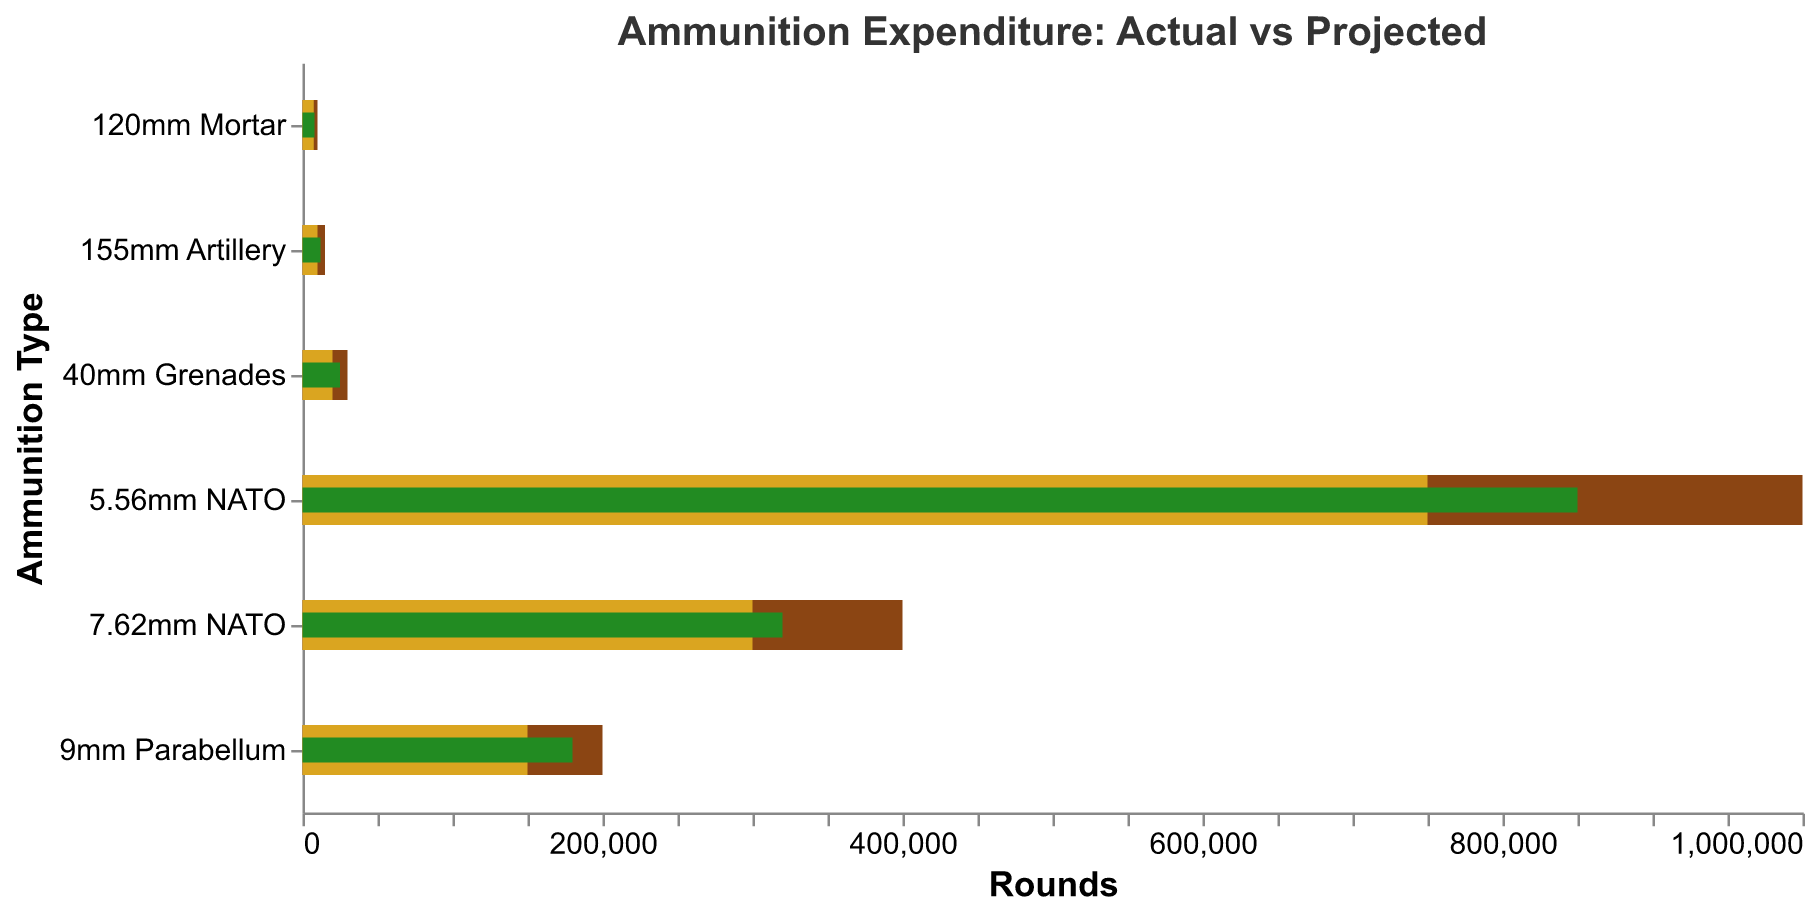How many different ammunition types are shown in the figure? Count the number of unique items listed on the y-axis.
Answer: 6 Which ammunition type has the highest actual expenditure? Compare the "Actual" values of all ammunition categories. The ammunition with the highest value is the one you seek.
Answer: 5.56mm NATO How does the actual expenditure compare to the projected expenditure for the 7.62mm NATO ammunition type? Subtract the "Projected" value from the "Actual" value for 7.62mm NATO.
Answer: 20000 more actual than projected Which ammunition type has the smallest difference between actual and projected expenditures? Calculate the absolute difference between the "Actual" and "Projected" values for each ammunition type, then identify the smallest difference.
Answer: 120mm Mortar How much higher is the projected expenditure than the actual expenditure for the 40mm Grenades? Subtract the "Actual" value from the "Projected" value for the 40mm Grenades. If the result is negative, it indicates the actual expenditure is higher.
Answer: Actual exceeds projected by 5000 Which ammunition type's actual expenditure exceeded its comparison threshold the most? Determine the difference between the "Actual" and "Comparison" values for each ammunition type and find the maximum difference.
Answer: 5.56mm NATO What is the total actual expenditure for all ammunition types combined? Sum all the "Actual" values. (850000 + 320000 + 180000 + 25000 + 8000 + 12000)
Answer: 1,395,000 Comparing the actual expenditures of the 9mm Parabellum and 155mm Artillery, which one was higher, and by how much? Subtract the "Actual" value of 155mm Artillery from the "Actual" value of 9mm Parabellum.
Answer: 9mm Parabellum is higher by 168,000 If you average the projected expenditures for all ammunition types, what value do you get? Sum the "Projected" values and divide by the number of ammunition types. (750000 + 300000 + 150000 + 20000 + 7500 + 10000) / 6
Answer: 209,250 